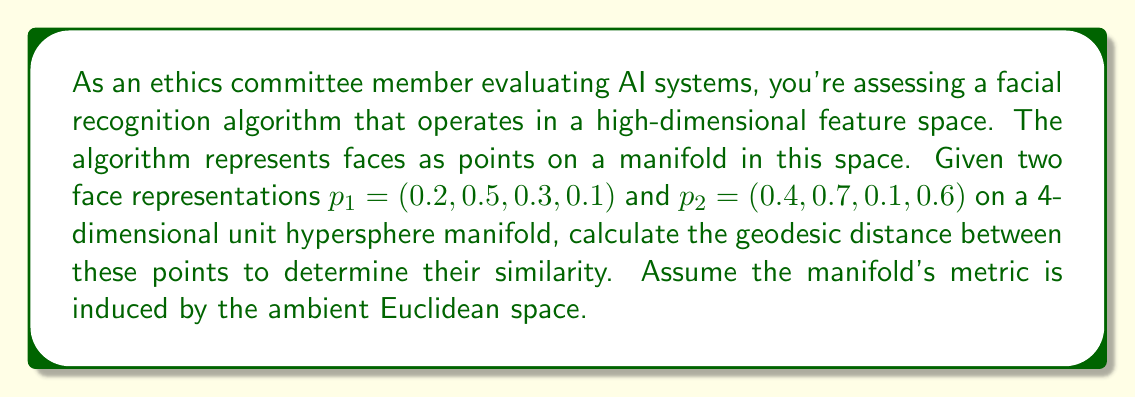Provide a solution to this math problem. To calculate the geodesic distance between two points on a hypersphere manifold, we can follow these steps:

1) For a unit hypersphere, the geodesic distance is proportional to the angle between the two vectors from the origin to the points. This angle is called the great circle distance.

2) The cosine of this angle can be calculated using the dot product of the two vectors:

   $$\cos(\theta) = \frac{p_1 \cdot p_2}{||p_1|| \cdot ||p_2||}$$

3) Since we're on a unit hypersphere, both vectors have unit length, so $||p_1|| = ||p_2|| = 1$. This simplifies our equation to:

   $$\cos(\theta) = p_1 \cdot p_2$$

4) Calculate the dot product:
   
   $$p_1 \cdot p_2 = (0.2)(0.4) + (0.5)(0.7) + (0.3)(0.1) + (0.1)(0.6)$$
   $$= 0.08 + 0.35 + 0.03 + 0.06 = 0.52$$

5) Now we have $\cos(\theta) = 0.52$

6) To get $\theta$, we take the arccosine:

   $$\theta = \arccos(0.52) \approx 1.0220 \text{ radians}$$

7) On a unit sphere, the geodesic distance is equal to this angle (in radians). If the sphere had a radius $r$, we would multiply by $r$.

Therefore, the geodesic distance is approximately 1.0220 radians or about 58.56 degrees.

This distance can be used to assess the similarity between the two face representations in the AI system, with smaller distances indicating greater similarity.
Answer: The geodesic distance between the two points is approximately 1.0220 radians or 58.56 degrees. 